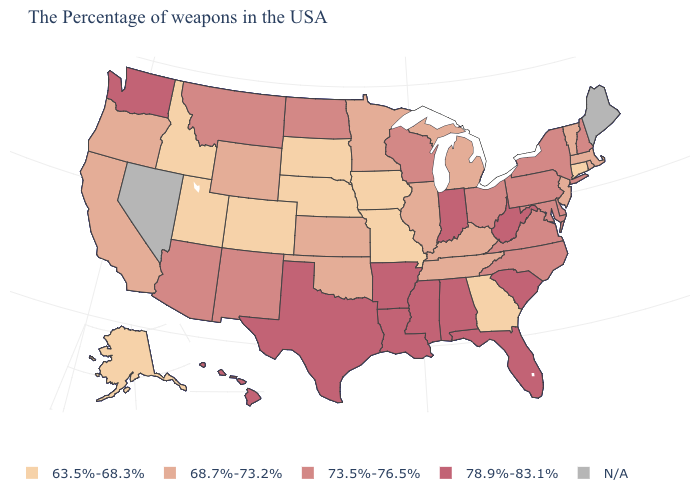Which states have the lowest value in the USA?
Short answer required. Connecticut, Georgia, Missouri, Iowa, Nebraska, South Dakota, Colorado, Utah, Idaho, Alaska. Is the legend a continuous bar?
Short answer required. No. What is the value of Oklahoma?
Concise answer only. 68.7%-73.2%. What is the value of Maryland?
Give a very brief answer. 73.5%-76.5%. What is the value of Texas?
Concise answer only. 78.9%-83.1%. Among the states that border North Dakota , which have the lowest value?
Give a very brief answer. South Dakota. Does Utah have the lowest value in the West?
Be succinct. Yes. What is the highest value in states that border Georgia?
Quick response, please. 78.9%-83.1%. What is the lowest value in states that border Texas?
Concise answer only. 68.7%-73.2%. What is the value of Iowa?
Give a very brief answer. 63.5%-68.3%. Among the states that border Texas , does Oklahoma have the lowest value?
Answer briefly. Yes. Among the states that border Virginia , does Tennessee have the lowest value?
Give a very brief answer. Yes. Which states have the lowest value in the USA?
Short answer required. Connecticut, Georgia, Missouri, Iowa, Nebraska, South Dakota, Colorado, Utah, Idaho, Alaska. 